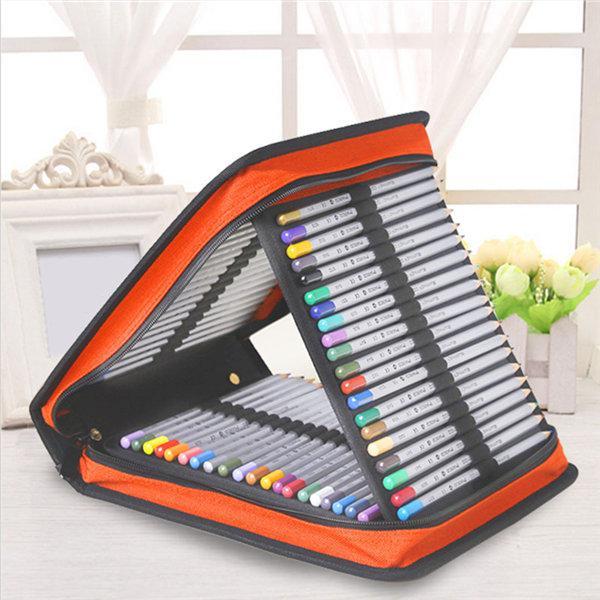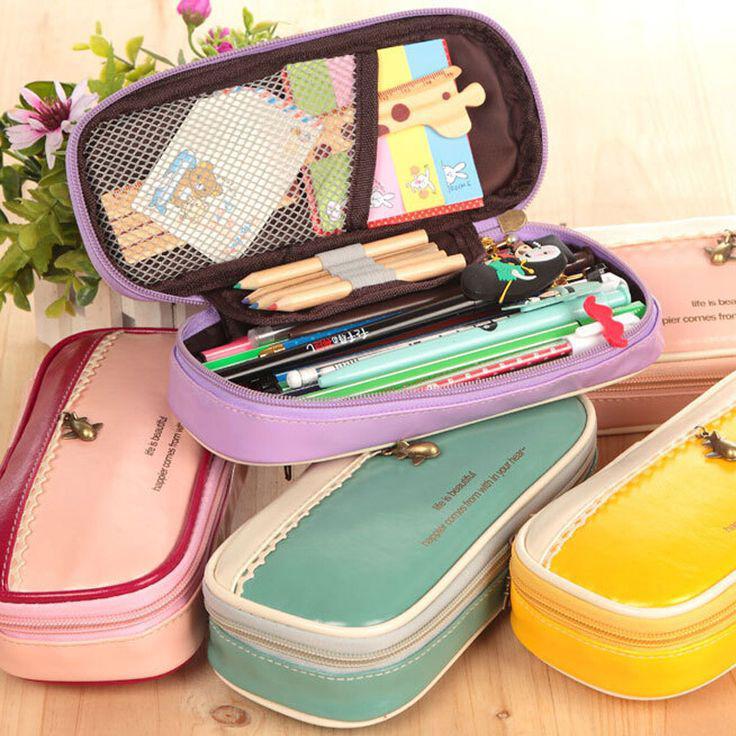The first image is the image on the left, the second image is the image on the right. Given the left and right images, does the statement "One image shows at least four cases in different solid colors with rounded edges, and only one is open and filled with supplies." hold true? Answer yes or no. Yes. The first image is the image on the left, the second image is the image on the right. Given the left and right images, does the statement "There is one image that includes only pencil cases zipped closed, and none are open." hold true? Answer yes or no. No. 